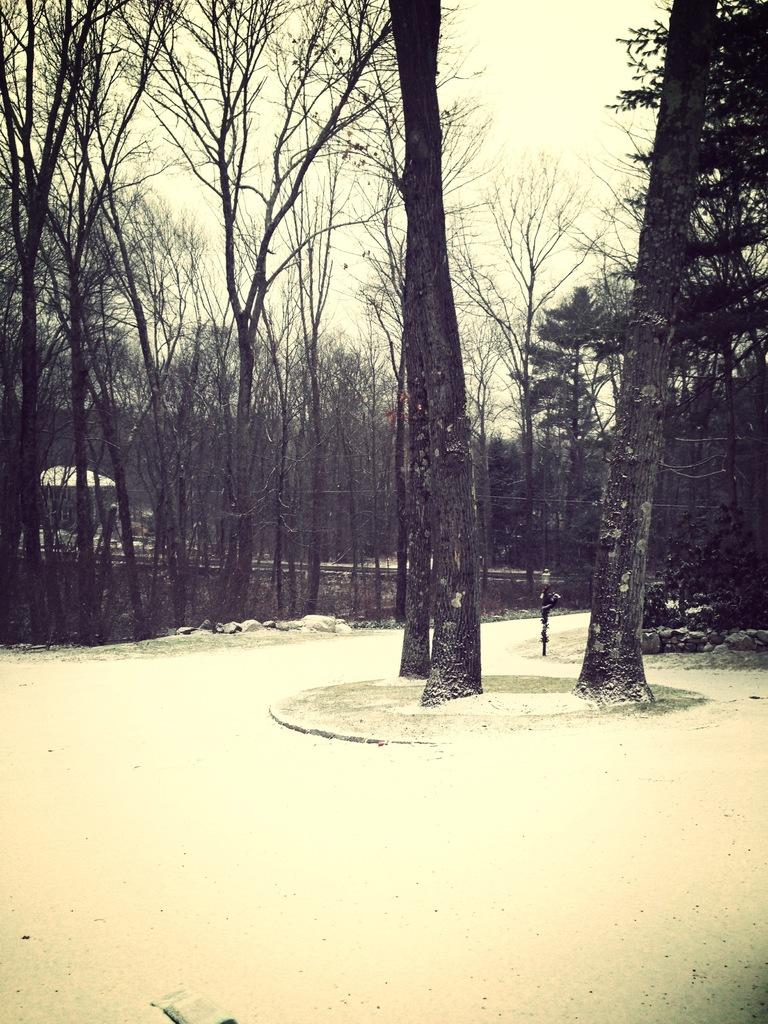What is the primary feature of the image? The primary feature of the image is the many trees. How are the trees positioned in relation to the ground? The trees are beside the ground. Is there any man-made structure visible in the image? Yes, there is a small tent in between the trees. What type of bait is being used to catch fish in the image? There is no indication of fishing or bait in the image; it primarily features trees and a small tent. 